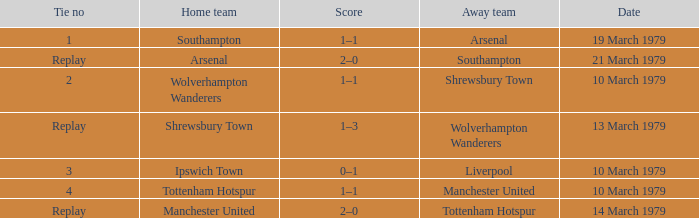Which tie number had an away team of Arsenal? 1.0. 